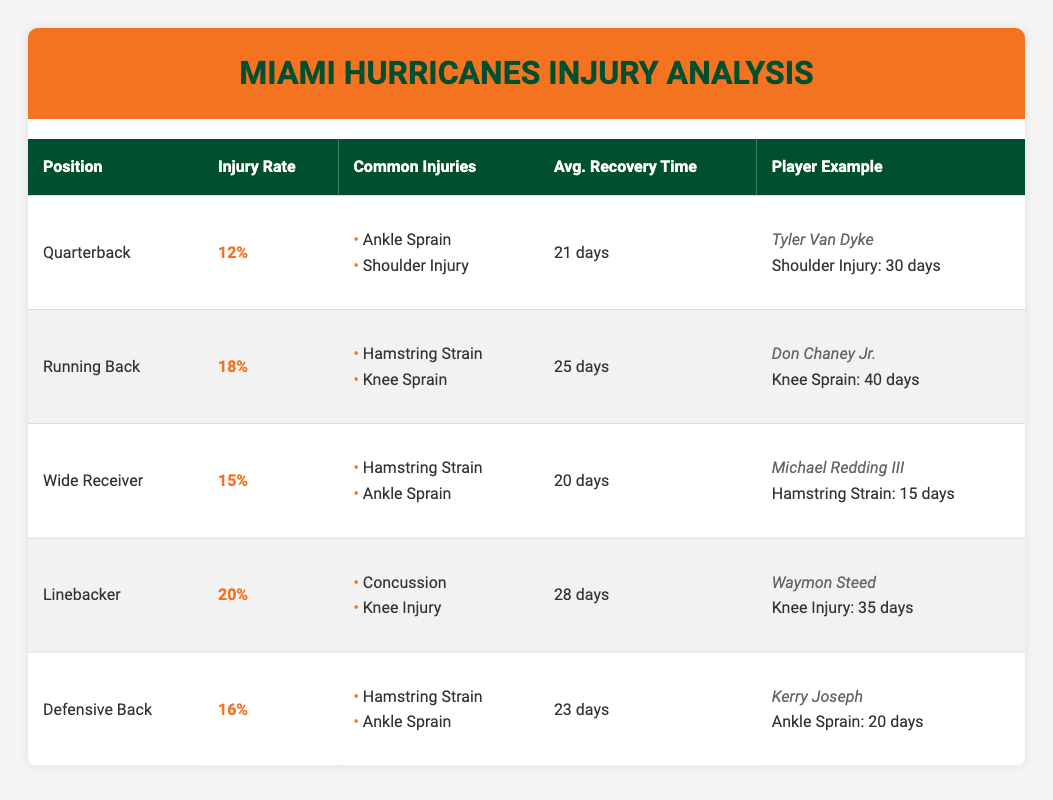What is the injury rate for the Quarterback position? The table shows that the injury rate for the Quarterback position is 0.12, or 12%. This information is directly stated in the relevant row under the "Injury Rate" column.
Answer: 12% Which position has the highest average recovery time? By comparing the "Avg. Recovery Time" for each position, the Linebacker position has the highest recovery time of 28 days, as shown in the table. Other positions have lower recovery times.
Answer: Linebacker Is the average recovery time for Wide Receivers longer than for Defensive Backs? The table specifies that Wide Receivers have an average recovery time of 20 days, while Defensive Backs have an average recovery time of 23 days. Thus, Wide Receivers do not have a longer recovery time.
Answer: No Which common injury is listed for Running Backs? The table indicates that Running Backs commonly suffer from Hamstring Strain and Knee Sprain, as listed under the "Common Injuries" column for that position.
Answer: Hamstring Strain, Knee Sprain What is the difference in injury rates between Linebackers and Wide Receivers? The injury rate for Linebackers is 0.20 (20%), while for Wide Receivers it is 0.15 (15%). The difference is found by subtracting the two rates: 0.20 - 0.15 = 0.05, or 5%.
Answer: 5% Do all players listed have recovery times that are shorter than their average position recovery time? By examining each player example: Tyler Van Dyke took 30 days for a shoulder injury (average 21 days), Don Chaney Jr. took 40 days (average 25 days), Michael Redding III took 15 days (average 20 days), Waymon Steed took 35 days (average 28 days), and Kerry Joseph took 20 days (average 23 days). The first three are longer than the average recovery time, therefore not all players have shorter recovery times.
Answer: No How many common injuries are listed for Defensive Backs? The table shows two common injuries for Defensive Backs, which are Hamstring Strain and Ankle Sprain. This is counted from the list provided under the "Common Injuries" column for that position.
Answer: 2 What is the average recovery time for the Running Back position? The average recovery time for Running Backs is stated in the table as 25 days, which can be directly referenced from the relevant row.
Answer: 25 days 